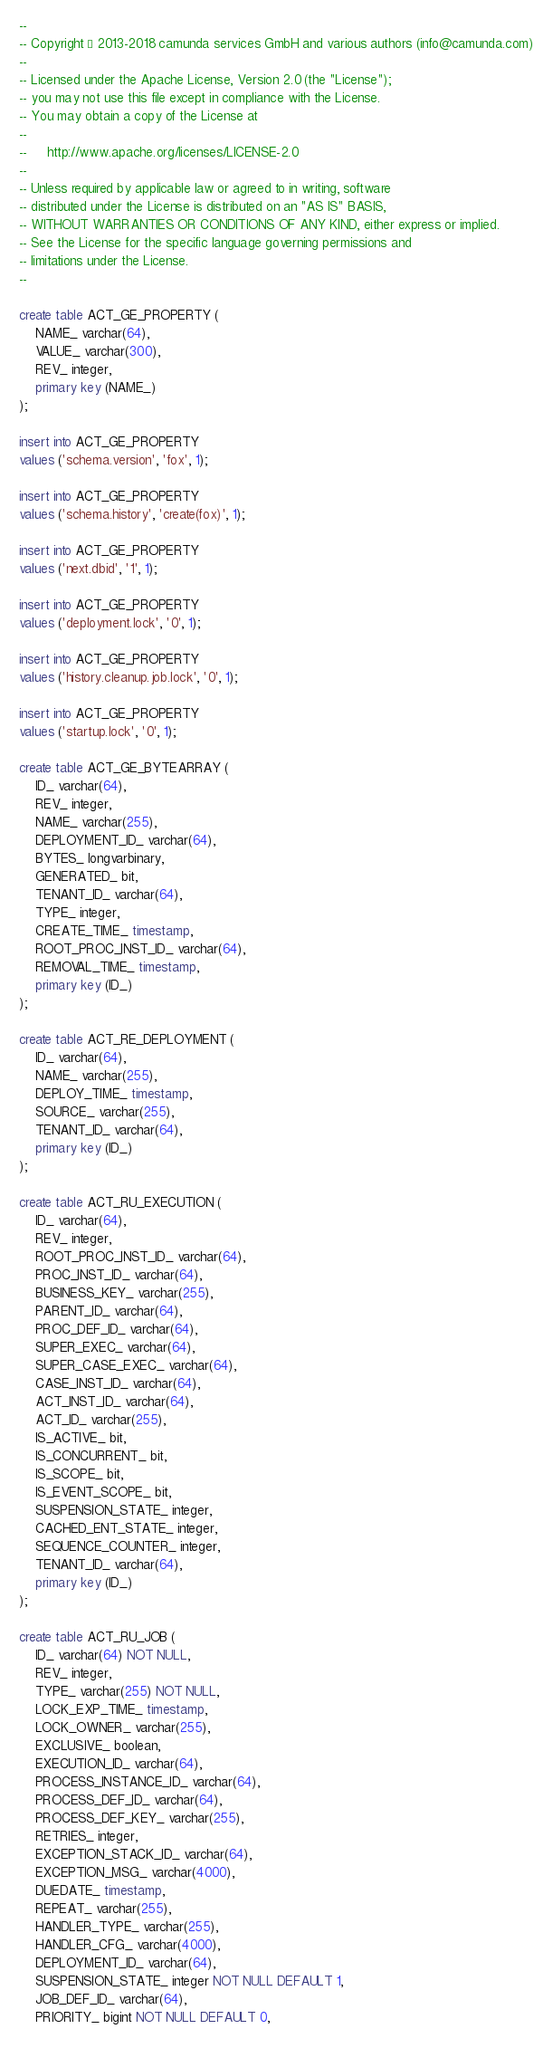<code> <loc_0><loc_0><loc_500><loc_500><_SQL_>--
-- Copyright © 2013-2018 camunda services GmbH and various authors (info@camunda.com)
--
-- Licensed under the Apache License, Version 2.0 (the "License");
-- you may not use this file except in compliance with the License.
-- You may obtain a copy of the License at
--
--     http://www.apache.org/licenses/LICENSE-2.0
--
-- Unless required by applicable law or agreed to in writing, software
-- distributed under the License is distributed on an "AS IS" BASIS,
-- WITHOUT WARRANTIES OR CONDITIONS OF ANY KIND, either express or implied.
-- See the License for the specific language governing permissions and
-- limitations under the License.
--

create table ACT_GE_PROPERTY (
    NAME_ varchar(64),
    VALUE_ varchar(300),
    REV_ integer,
    primary key (NAME_)
);

insert into ACT_GE_PROPERTY
values ('schema.version', 'fox', 1);

insert into ACT_GE_PROPERTY
values ('schema.history', 'create(fox)', 1);

insert into ACT_GE_PROPERTY
values ('next.dbid', '1', 1);

insert into ACT_GE_PROPERTY
values ('deployment.lock', '0', 1);

insert into ACT_GE_PROPERTY
values ('history.cleanup.job.lock', '0', 1);

insert into ACT_GE_PROPERTY
values ('startup.lock', '0', 1);

create table ACT_GE_BYTEARRAY (
    ID_ varchar(64),
    REV_ integer,
    NAME_ varchar(255),
    DEPLOYMENT_ID_ varchar(64),
    BYTES_ longvarbinary,
    GENERATED_ bit,
    TENANT_ID_ varchar(64),
    TYPE_ integer,
    CREATE_TIME_ timestamp,
    ROOT_PROC_INST_ID_ varchar(64),
    REMOVAL_TIME_ timestamp,
    primary key (ID_)
);

create table ACT_RE_DEPLOYMENT (
    ID_ varchar(64),
    NAME_ varchar(255),
    DEPLOY_TIME_ timestamp,
    SOURCE_ varchar(255),
    TENANT_ID_ varchar(64),
    primary key (ID_)
);

create table ACT_RU_EXECUTION (
    ID_ varchar(64),
    REV_ integer,
    ROOT_PROC_INST_ID_ varchar(64),
    PROC_INST_ID_ varchar(64),
    BUSINESS_KEY_ varchar(255),
    PARENT_ID_ varchar(64),
    PROC_DEF_ID_ varchar(64),
    SUPER_EXEC_ varchar(64),
    SUPER_CASE_EXEC_ varchar(64),
    CASE_INST_ID_ varchar(64),
    ACT_INST_ID_ varchar(64),
    ACT_ID_ varchar(255),
    IS_ACTIVE_ bit,
    IS_CONCURRENT_ bit,
    IS_SCOPE_ bit,
    IS_EVENT_SCOPE_ bit,
    SUSPENSION_STATE_ integer,
    CACHED_ENT_STATE_ integer,
    SEQUENCE_COUNTER_ integer,
    TENANT_ID_ varchar(64),
    primary key (ID_)
);

create table ACT_RU_JOB (
    ID_ varchar(64) NOT NULL,
    REV_ integer,
    TYPE_ varchar(255) NOT NULL,
    LOCK_EXP_TIME_ timestamp,
    LOCK_OWNER_ varchar(255),
    EXCLUSIVE_ boolean,
    EXECUTION_ID_ varchar(64),
    PROCESS_INSTANCE_ID_ varchar(64),
    PROCESS_DEF_ID_ varchar(64),
    PROCESS_DEF_KEY_ varchar(255),
    RETRIES_ integer,
    EXCEPTION_STACK_ID_ varchar(64),
    EXCEPTION_MSG_ varchar(4000),
    DUEDATE_ timestamp,
    REPEAT_ varchar(255),
    HANDLER_TYPE_ varchar(255),
    HANDLER_CFG_ varchar(4000),
    DEPLOYMENT_ID_ varchar(64),
    SUSPENSION_STATE_ integer NOT NULL DEFAULT 1,
    JOB_DEF_ID_ varchar(64),
    PRIORITY_ bigint NOT NULL DEFAULT 0,</code> 